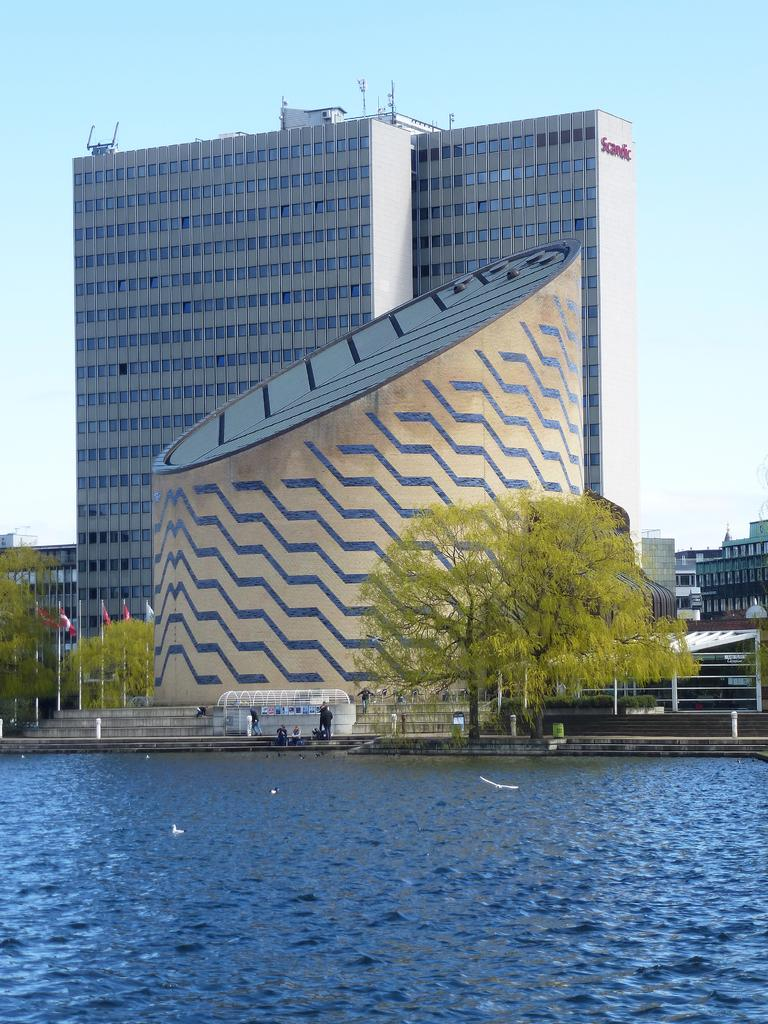What type of natural body of water is present in the image? There is a lake in the image. What type of vegetation can be seen in the image? There are trees in the image. What is located in front of the building in the image? There are flags in front of a building. What can be seen in the background of the image? The sky is visible in the background of the image. What type of instrument is being played by the ocean in the image? There is no ocean or instrument present in the image. What type of machine can be seen operating near the lake in the image? There is no machine present in the image; it only features a lake, trees, flags, and a building. 